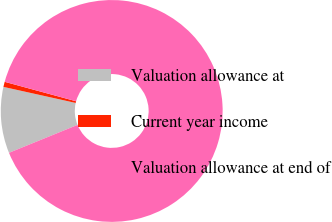<chart> <loc_0><loc_0><loc_500><loc_500><pie_chart><fcel>Valuation allowance at<fcel>Current year income<fcel>Valuation allowance at end of<nl><fcel>9.64%<fcel>0.75%<fcel>89.61%<nl></chart> 